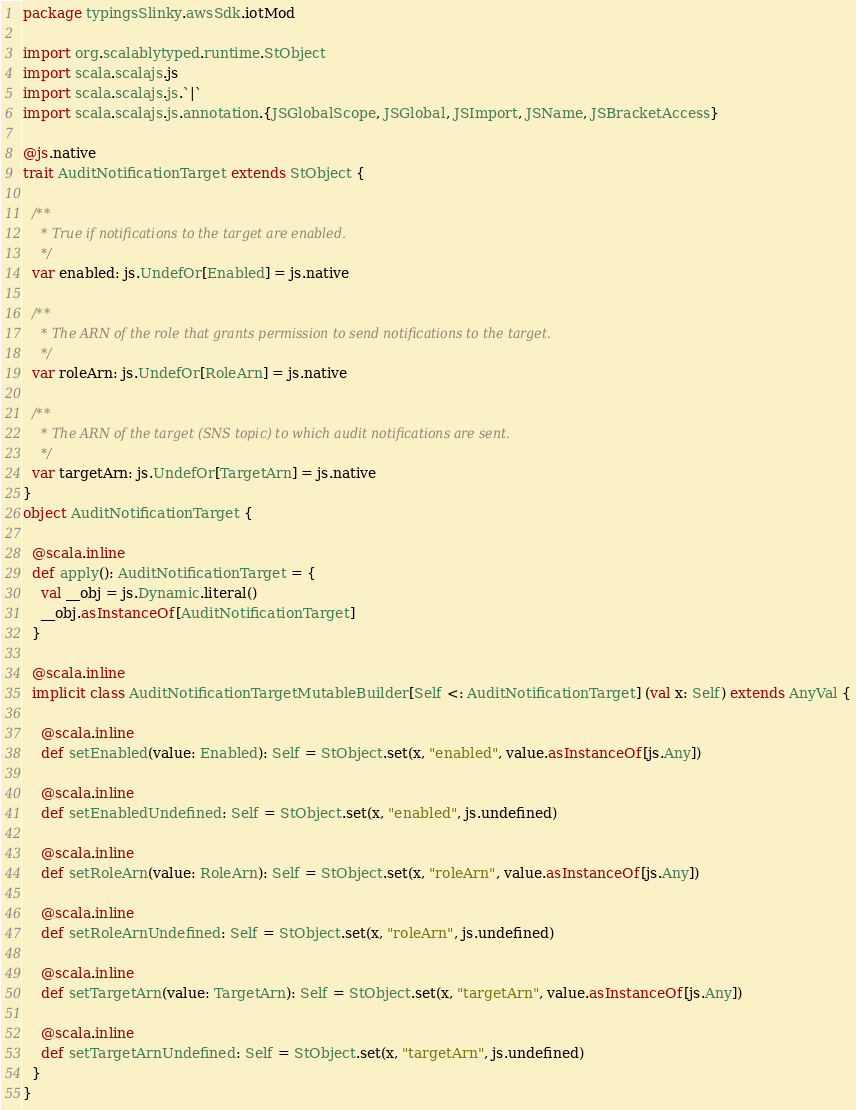Convert code to text. <code><loc_0><loc_0><loc_500><loc_500><_Scala_>package typingsSlinky.awsSdk.iotMod

import org.scalablytyped.runtime.StObject
import scala.scalajs.js
import scala.scalajs.js.`|`
import scala.scalajs.js.annotation.{JSGlobalScope, JSGlobal, JSImport, JSName, JSBracketAccess}

@js.native
trait AuditNotificationTarget extends StObject {
  
  /**
    * True if notifications to the target are enabled.
    */
  var enabled: js.UndefOr[Enabled] = js.native
  
  /**
    * The ARN of the role that grants permission to send notifications to the target.
    */
  var roleArn: js.UndefOr[RoleArn] = js.native
  
  /**
    * The ARN of the target (SNS topic) to which audit notifications are sent.
    */
  var targetArn: js.UndefOr[TargetArn] = js.native
}
object AuditNotificationTarget {
  
  @scala.inline
  def apply(): AuditNotificationTarget = {
    val __obj = js.Dynamic.literal()
    __obj.asInstanceOf[AuditNotificationTarget]
  }
  
  @scala.inline
  implicit class AuditNotificationTargetMutableBuilder[Self <: AuditNotificationTarget] (val x: Self) extends AnyVal {
    
    @scala.inline
    def setEnabled(value: Enabled): Self = StObject.set(x, "enabled", value.asInstanceOf[js.Any])
    
    @scala.inline
    def setEnabledUndefined: Self = StObject.set(x, "enabled", js.undefined)
    
    @scala.inline
    def setRoleArn(value: RoleArn): Self = StObject.set(x, "roleArn", value.asInstanceOf[js.Any])
    
    @scala.inline
    def setRoleArnUndefined: Self = StObject.set(x, "roleArn", js.undefined)
    
    @scala.inline
    def setTargetArn(value: TargetArn): Self = StObject.set(x, "targetArn", value.asInstanceOf[js.Any])
    
    @scala.inline
    def setTargetArnUndefined: Self = StObject.set(x, "targetArn", js.undefined)
  }
}
</code> 